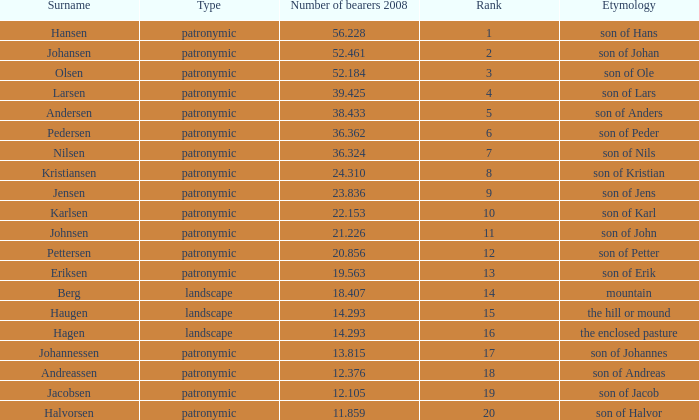What is Type, when Rank is greater than 6, when Number of Bearers 2008 is greater than 13.815, and when Surname is Eriksen? Patronymic. 